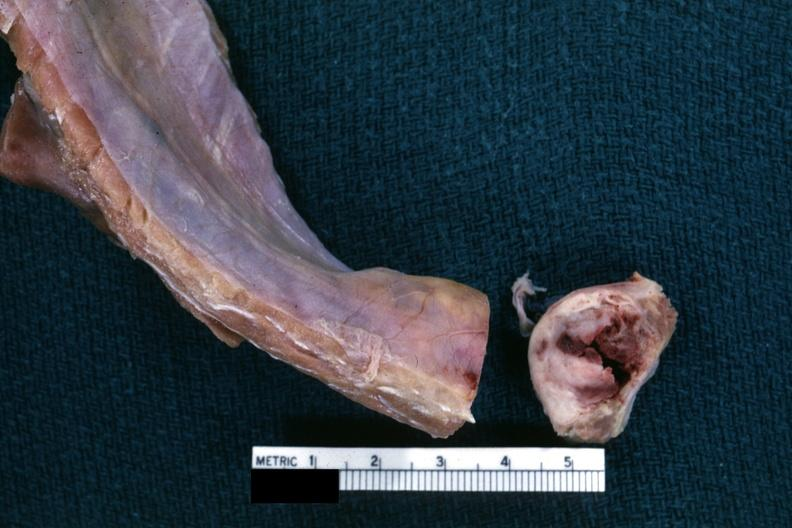does this image show obvious nodular rib lesion cross sectioned to show white neoplasm with central hemorrhage?
Answer the question using a single word or phrase. Yes 